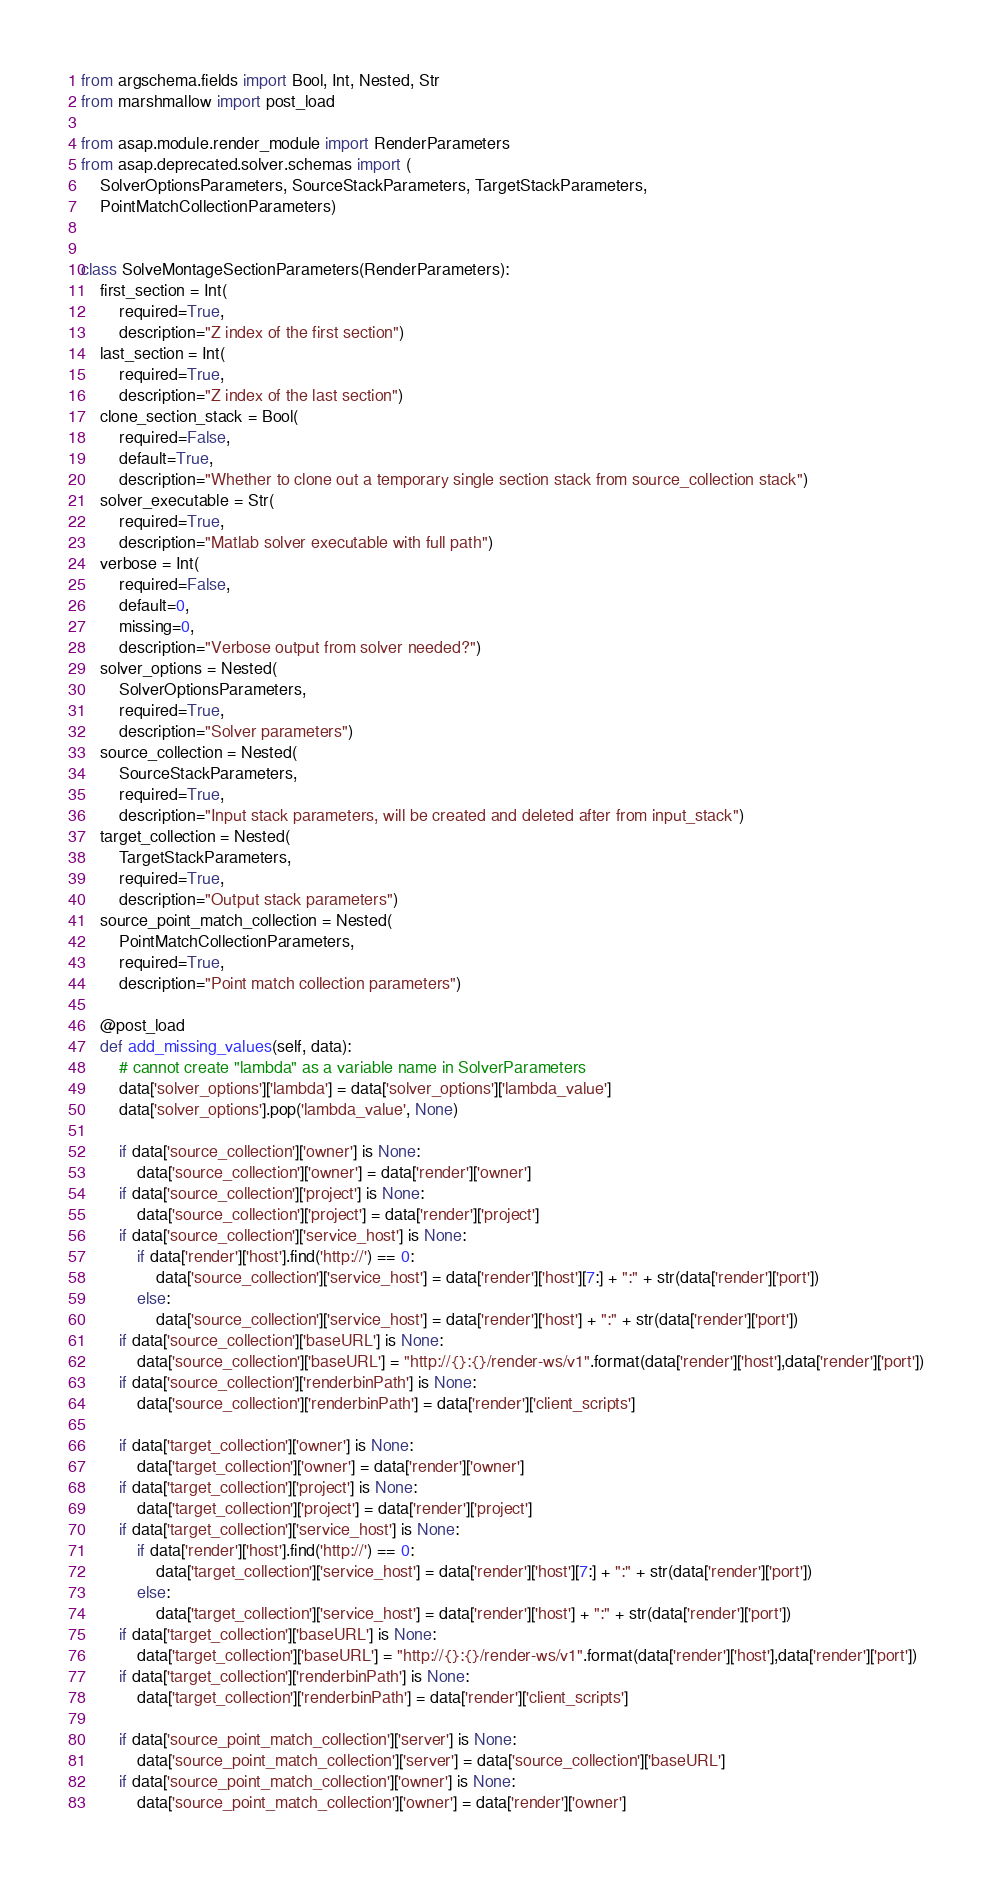<code> <loc_0><loc_0><loc_500><loc_500><_Python_>from argschema.fields import Bool, Int, Nested, Str
from marshmallow import post_load

from asap.module.render_module import RenderParameters
from asap.deprecated.solver.schemas import (
    SolverOptionsParameters, SourceStackParameters, TargetStackParameters,
    PointMatchCollectionParameters)


class SolveMontageSectionParameters(RenderParameters):
    first_section = Int(
        required=True,
        description="Z index of the first section")
    last_section = Int(
        required=True,
        description="Z index of the last section")
    clone_section_stack = Bool(
        required=False,
        default=True,
        description="Whether to clone out a temporary single section stack from source_collection stack")
    solver_executable = Str(
        required=True,
        description="Matlab solver executable with full path")
    verbose = Int(
        required=False,
        default=0,
        missing=0,
        description="Verbose output from solver needed?")
    solver_options = Nested(
        SolverOptionsParameters,
        required=True,
        description="Solver parameters")
    source_collection = Nested(
        SourceStackParameters,
        required=True,
        description="Input stack parameters, will be created and deleted after from input_stack")
    target_collection = Nested(
        TargetStackParameters,
        required=True,
        description="Output stack parameters")
    source_point_match_collection = Nested(
        PointMatchCollectionParameters,
        required=True,
        description="Point match collection parameters")

    @post_load
    def add_missing_values(self, data):
        # cannot create "lambda" as a variable name in SolverParameters
        data['solver_options']['lambda'] = data['solver_options']['lambda_value']
        data['solver_options'].pop('lambda_value', None)

        if data['source_collection']['owner'] is None:
            data['source_collection']['owner'] = data['render']['owner']
        if data['source_collection']['project'] is None:
            data['source_collection']['project'] = data['render']['project']
        if data['source_collection']['service_host'] is None:
            if data['render']['host'].find('http://') == 0:
                data['source_collection']['service_host'] = data['render']['host'][7:] + ":" + str(data['render']['port'])
            else:
                data['source_collection']['service_host'] = data['render']['host'] + ":" + str(data['render']['port'])
        if data['source_collection']['baseURL'] is None:
            data['source_collection']['baseURL'] = "http://{}:{}/render-ws/v1".format(data['render']['host'],data['render']['port'])
        if data['source_collection']['renderbinPath'] is None:
            data['source_collection']['renderbinPath'] = data['render']['client_scripts']

        if data['target_collection']['owner'] is None:
            data['target_collection']['owner'] = data['render']['owner']
        if data['target_collection']['project'] is None:
            data['target_collection']['project'] = data['render']['project']
        if data['target_collection']['service_host'] is None:
            if data['render']['host'].find('http://') == 0:
                data['target_collection']['service_host'] = data['render']['host'][7:] + ":" + str(data['render']['port'])
            else:
                data['target_collection']['service_host'] = data['render']['host'] + ":" + str(data['render']['port'])
        if data['target_collection']['baseURL'] is None:
            data['target_collection']['baseURL'] = "http://{}:{}/render-ws/v1".format(data['render']['host'],data['render']['port'])
        if data['target_collection']['renderbinPath'] is None:
            data['target_collection']['renderbinPath'] = data['render']['client_scripts']

        if data['source_point_match_collection']['server'] is None:
            data['source_point_match_collection']['server'] = data['source_collection']['baseURL']
        if data['source_point_match_collection']['owner'] is None:
            data['source_point_match_collection']['owner'] = data['render']['owner']
</code> 